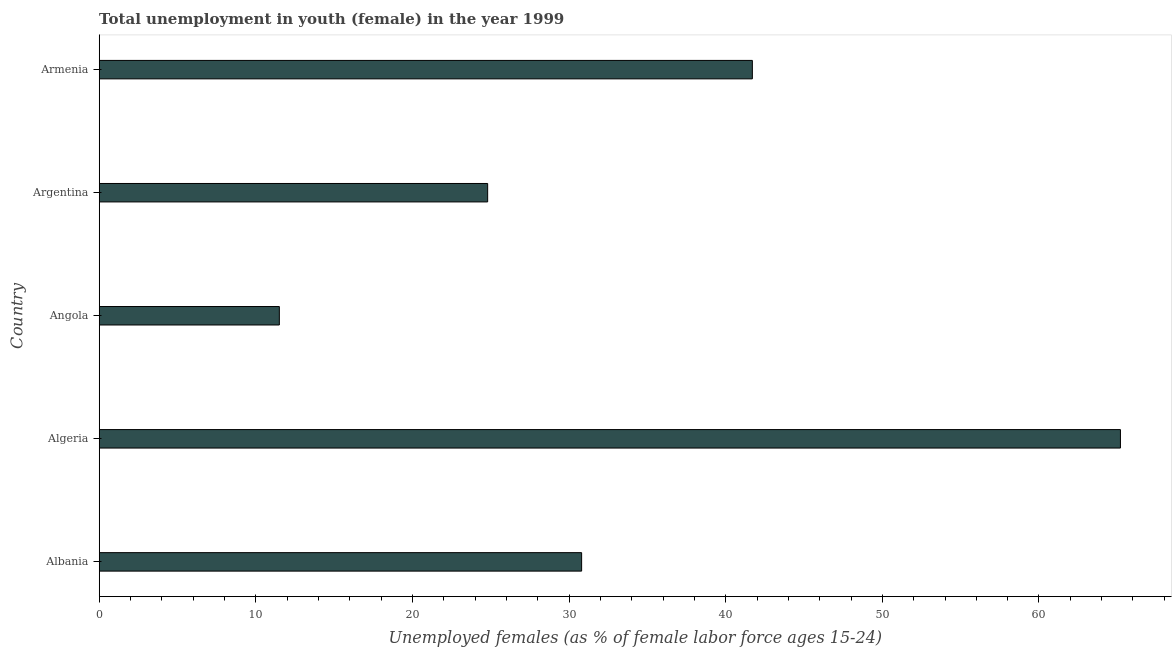Does the graph contain any zero values?
Provide a succinct answer. No. What is the title of the graph?
Your answer should be compact. Total unemployment in youth (female) in the year 1999. What is the label or title of the X-axis?
Provide a succinct answer. Unemployed females (as % of female labor force ages 15-24). What is the unemployed female youth population in Angola?
Your answer should be very brief. 11.5. Across all countries, what is the maximum unemployed female youth population?
Your answer should be very brief. 65.2. In which country was the unemployed female youth population maximum?
Your response must be concise. Algeria. In which country was the unemployed female youth population minimum?
Make the answer very short. Angola. What is the sum of the unemployed female youth population?
Your answer should be compact. 174. What is the difference between the unemployed female youth population in Algeria and Argentina?
Keep it short and to the point. 40.4. What is the average unemployed female youth population per country?
Ensure brevity in your answer.  34.8. What is the median unemployed female youth population?
Your response must be concise. 30.8. In how many countries, is the unemployed female youth population greater than 10 %?
Give a very brief answer. 5. What is the ratio of the unemployed female youth population in Algeria to that in Armenia?
Make the answer very short. 1.56. Is the difference between the unemployed female youth population in Algeria and Armenia greater than the difference between any two countries?
Your answer should be compact. No. What is the difference between the highest and the second highest unemployed female youth population?
Offer a terse response. 23.5. What is the difference between the highest and the lowest unemployed female youth population?
Offer a very short reply. 53.7. Are the values on the major ticks of X-axis written in scientific E-notation?
Offer a very short reply. No. What is the Unemployed females (as % of female labor force ages 15-24) in Albania?
Your answer should be very brief. 30.8. What is the Unemployed females (as % of female labor force ages 15-24) of Algeria?
Keep it short and to the point. 65.2. What is the Unemployed females (as % of female labor force ages 15-24) of Angola?
Keep it short and to the point. 11.5. What is the Unemployed females (as % of female labor force ages 15-24) of Argentina?
Offer a very short reply. 24.8. What is the Unemployed females (as % of female labor force ages 15-24) in Armenia?
Offer a terse response. 41.7. What is the difference between the Unemployed females (as % of female labor force ages 15-24) in Albania and Algeria?
Make the answer very short. -34.4. What is the difference between the Unemployed females (as % of female labor force ages 15-24) in Albania and Angola?
Provide a short and direct response. 19.3. What is the difference between the Unemployed females (as % of female labor force ages 15-24) in Albania and Argentina?
Offer a terse response. 6. What is the difference between the Unemployed females (as % of female labor force ages 15-24) in Algeria and Angola?
Offer a very short reply. 53.7. What is the difference between the Unemployed females (as % of female labor force ages 15-24) in Algeria and Argentina?
Offer a very short reply. 40.4. What is the difference between the Unemployed females (as % of female labor force ages 15-24) in Angola and Armenia?
Ensure brevity in your answer.  -30.2. What is the difference between the Unemployed females (as % of female labor force ages 15-24) in Argentina and Armenia?
Your answer should be very brief. -16.9. What is the ratio of the Unemployed females (as % of female labor force ages 15-24) in Albania to that in Algeria?
Offer a very short reply. 0.47. What is the ratio of the Unemployed females (as % of female labor force ages 15-24) in Albania to that in Angola?
Offer a terse response. 2.68. What is the ratio of the Unemployed females (as % of female labor force ages 15-24) in Albania to that in Argentina?
Offer a very short reply. 1.24. What is the ratio of the Unemployed females (as % of female labor force ages 15-24) in Albania to that in Armenia?
Offer a very short reply. 0.74. What is the ratio of the Unemployed females (as % of female labor force ages 15-24) in Algeria to that in Angola?
Ensure brevity in your answer.  5.67. What is the ratio of the Unemployed females (as % of female labor force ages 15-24) in Algeria to that in Argentina?
Provide a short and direct response. 2.63. What is the ratio of the Unemployed females (as % of female labor force ages 15-24) in Algeria to that in Armenia?
Provide a short and direct response. 1.56. What is the ratio of the Unemployed females (as % of female labor force ages 15-24) in Angola to that in Argentina?
Ensure brevity in your answer.  0.46. What is the ratio of the Unemployed females (as % of female labor force ages 15-24) in Angola to that in Armenia?
Make the answer very short. 0.28. What is the ratio of the Unemployed females (as % of female labor force ages 15-24) in Argentina to that in Armenia?
Provide a short and direct response. 0.59. 